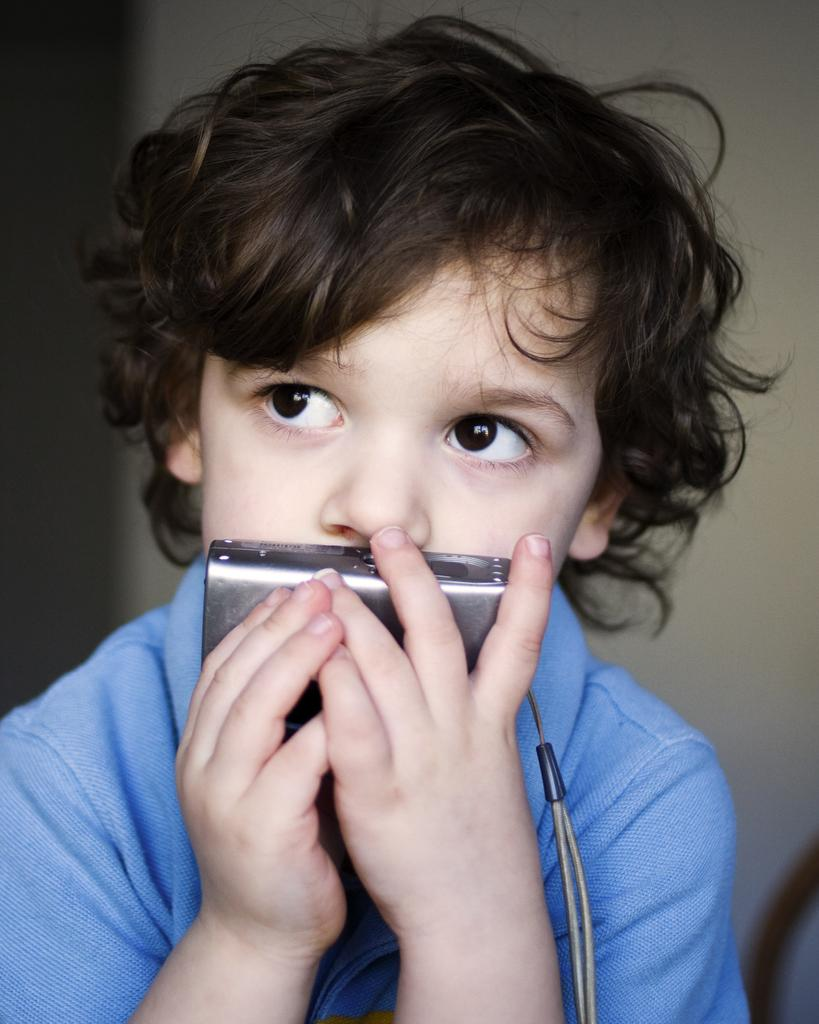Who is the main subject in the image? There is a boy in the image. What is the boy holding in his hand? The boy is holding a camera in his hand. What advice is the boy giving to the spiders on the bridge in the image? There are no spiders or bridges present in the image; it only features a boy holding a camera. 